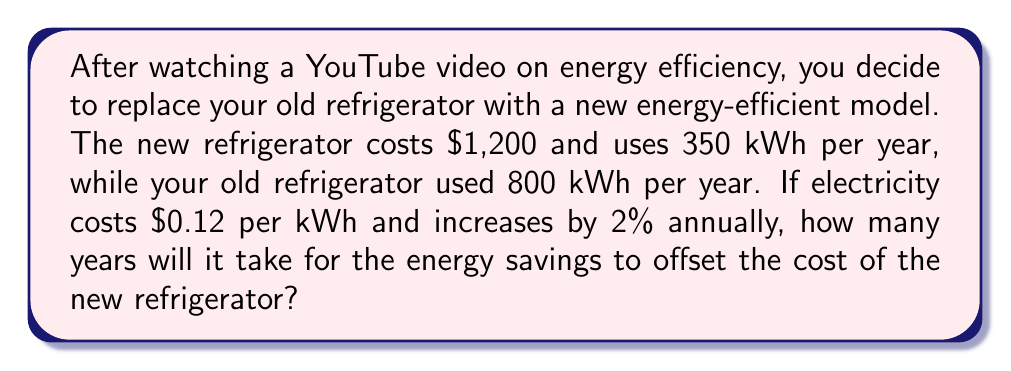What is the answer to this math problem? Let's approach this problem step-by-step:

1) First, calculate the annual energy savings:
   $800 \text{ kWh} - 350 \text{ kWh} = 450 \text{ kWh}$

2) Calculate the initial annual cost savings:
   $450 \text{ kWh} \times \$0.12/\text{kWh} = \$54$

3) We need to account for the 2% annual increase in electricity costs. Let's express the savings in year $n$ as:

   $S_n = 54 \times (1.02)^{n-1}$

4) The total savings after $n$ years can be expressed as the sum of a geometric series:

   $\text{Total Savings} = \sum_{i=1}^n 54 \times (1.02)^{i-1}$

5) We can simplify this using the formula for the sum of a geometric series:

   $\text{Total Savings} = 54 \times \frac{1 - (1.02)^n}{1 - 1.02} = 2700 \times (1 - (1.02)^n)$

6) We want to find $n$ where the total savings equal the cost of the new refrigerator:

   $2700 \times (1 - (1.02)^n) = 1200$

7) Solving for $n$:

   $1 - (1.02)^n = \frac{1200}{2700} = \frac{4}{9}$
   $(1.02)^n = \frac{5}{9}$
   $n \times \ln(1.02) = \ln(\frac{5}{9})$
   $n = \frac{\ln(\frac{5}{9})}{\ln(1.02)} \approx 13.76$

8) Since we can't have a partial year, we round up to the next whole number.
Answer: It will take 14 years for the energy savings to offset the cost of the new refrigerator. 